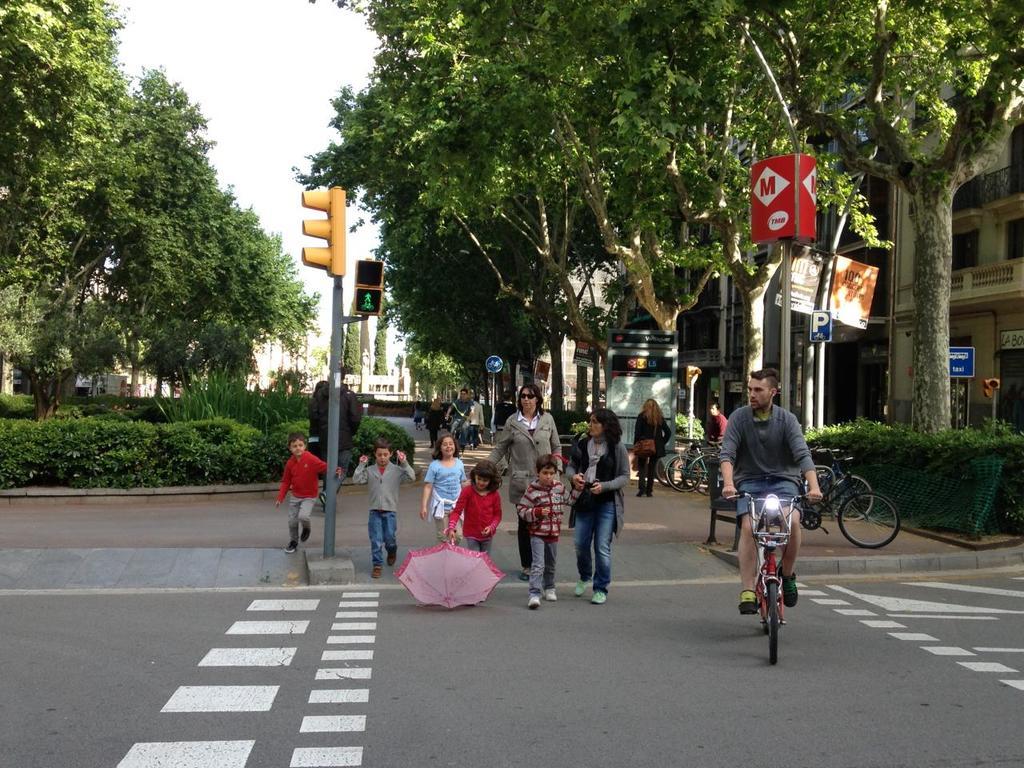What is written on the red sign?
Offer a very short reply. M. Is the big m red?
Make the answer very short. Yes. 